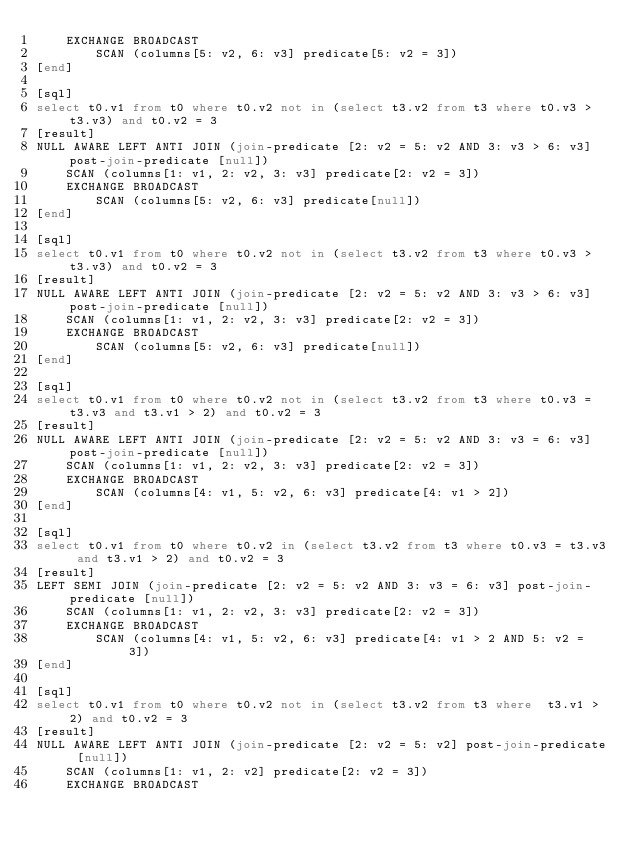<code> <loc_0><loc_0><loc_500><loc_500><_SQL_>    EXCHANGE BROADCAST
        SCAN (columns[5: v2, 6: v3] predicate[5: v2 = 3])
[end]

[sql]
select t0.v1 from t0 where t0.v2 not in (select t3.v2 from t3 where t0.v3 > t3.v3) and t0.v2 = 3
[result]
NULL AWARE LEFT ANTI JOIN (join-predicate [2: v2 = 5: v2 AND 3: v3 > 6: v3] post-join-predicate [null])
    SCAN (columns[1: v1, 2: v2, 3: v3] predicate[2: v2 = 3])
    EXCHANGE BROADCAST
        SCAN (columns[5: v2, 6: v3] predicate[null])
[end]

[sql]
select t0.v1 from t0 where t0.v2 not in (select t3.v2 from t3 where t0.v3 > t3.v3) and t0.v2 = 3
[result]
NULL AWARE LEFT ANTI JOIN (join-predicate [2: v2 = 5: v2 AND 3: v3 > 6: v3] post-join-predicate [null])
    SCAN (columns[1: v1, 2: v2, 3: v3] predicate[2: v2 = 3])
    EXCHANGE BROADCAST
        SCAN (columns[5: v2, 6: v3] predicate[null])
[end]

[sql]
select t0.v1 from t0 where t0.v2 not in (select t3.v2 from t3 where t0.v3 = t3.v3 and t3.v1 > 2) and t0.v2 = 3
[result]
NULL AWARE LEFT ANTI JOIN (join-predicate [2: v2 = 5: v2 AND 3: v3 = 6: v3] post-join-predicate [null])
    SCAN (columns[1: v1, 2: v2, 3: v3] predicate[2: v2 = 3])
    EXCHANGE BROADCAST
        SCAN (columns[4: v1, 5: v2, 6: v3] predicate[4: v1 > 2])
[end]

[sql]
select t0.v1 from t0 where t0.v2 in (select t3.v2 from t3 where t0.v3 = t3.v3 and t3.v1 > 2) and t0.v2 = 3
[result]
LEFT SEMI JOIN (join-predicate [2: v2 = 5: v2 AND 3: v3 = 6: v3] post-join-predicate [null])
    SCAN (columns[1: v1, 2: v2, 3: v3] predicate[2: v2 = 3])
    EXCHANGE BROADCAST
        SCAN (columns[4: v1, 5: v2, 6: v3] predicate[4: v1 > 2 AND 5: v2 = 3])
[end]

[sql]
select t0.v1 from t0 where t0.v2 not in (select t3.v2 from t3 where  t3.v1 > 2) and t0.v2 = 3
[result]
NULL AWARE LEFT ANTI JOIN (join-predicate [2: v2 = 5: v2] post-join-predicate [null])
    SCAN (columns[1: v1, 2: v2] predicate[2: v2 = 3])
    EXCHANGE BROADCAST</code> 